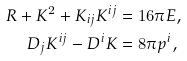<formula> <loc_0><loc_0><loc_500><loc_500>R + K ^ { 2 } + K _ { i j } K ^ { i j } & = 1 6 \pi E , \\ D _ { j } K ^ { i j } - D ^ { i } K & = 8 \pi p ^ { i } ,</formula> 